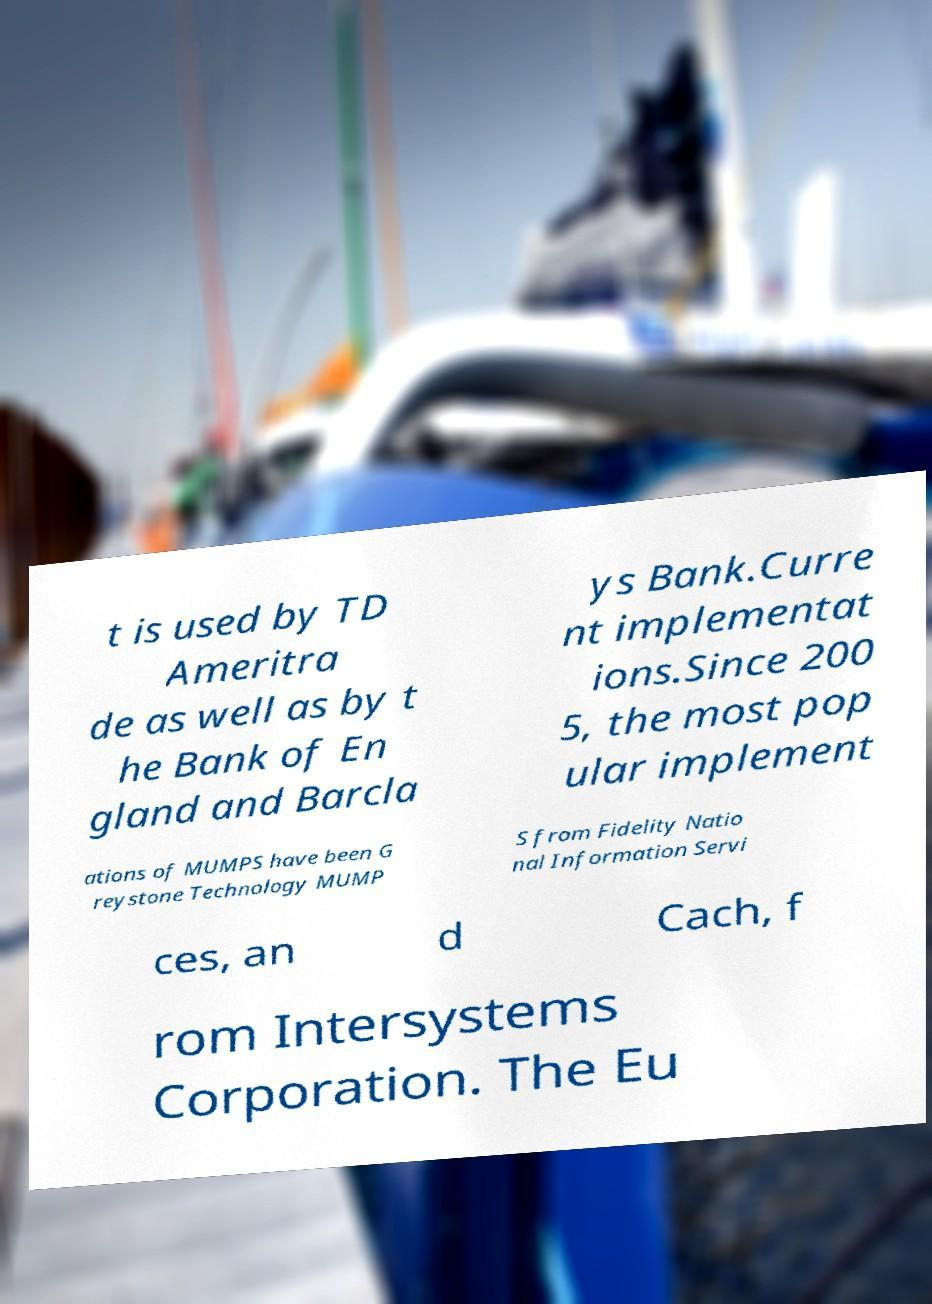There's text embedded in this image that I need extracted. Can you transcribe it verbatim? t is used by TD Ameritra de as well as by t he Bank of En gland and Barcla ys Bank.Curre nt implementat ions.Since 200 5, the most pop ular implement ations of MUMPS have been G reystone Technology MUMP S from Fidelity Natio nal Information Servi ces, an d Cach, f rom Intersystems Corporation. The Eu 